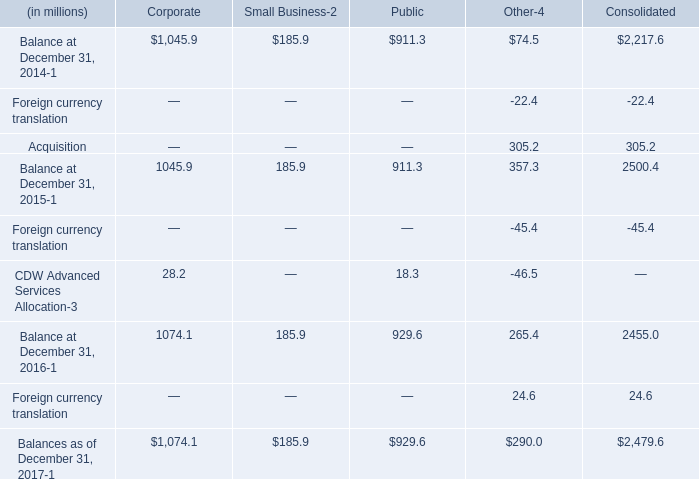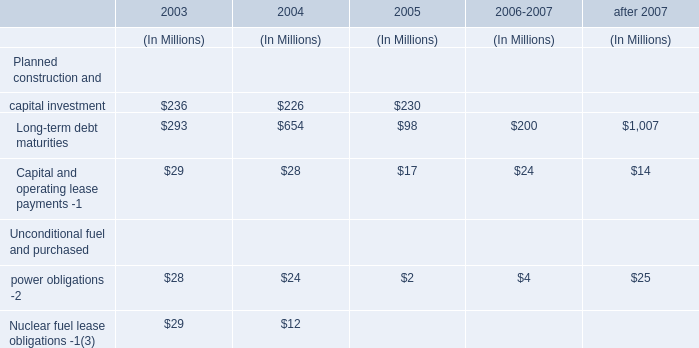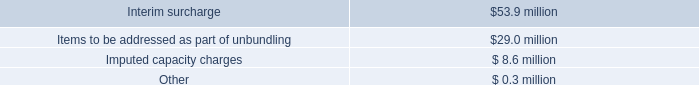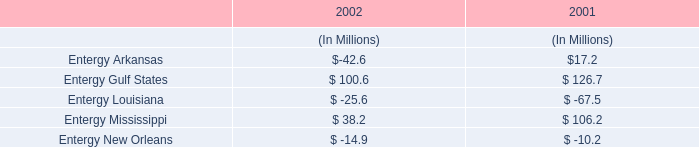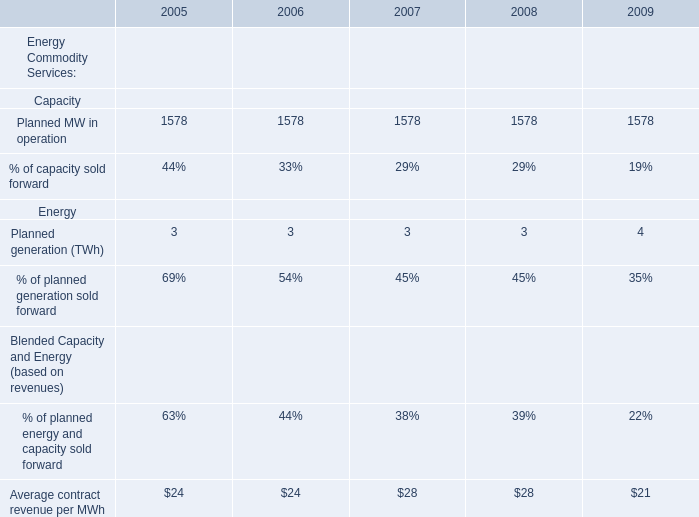what's the total amount of Planned MW in operation of 2009, Balances as of December 31, 2017 of Corporate, and Planned MW in operation of 2007 ? 
Computations: ((1578.0 + 1074.1) + 1578.0)
Answer: 4230.1. 